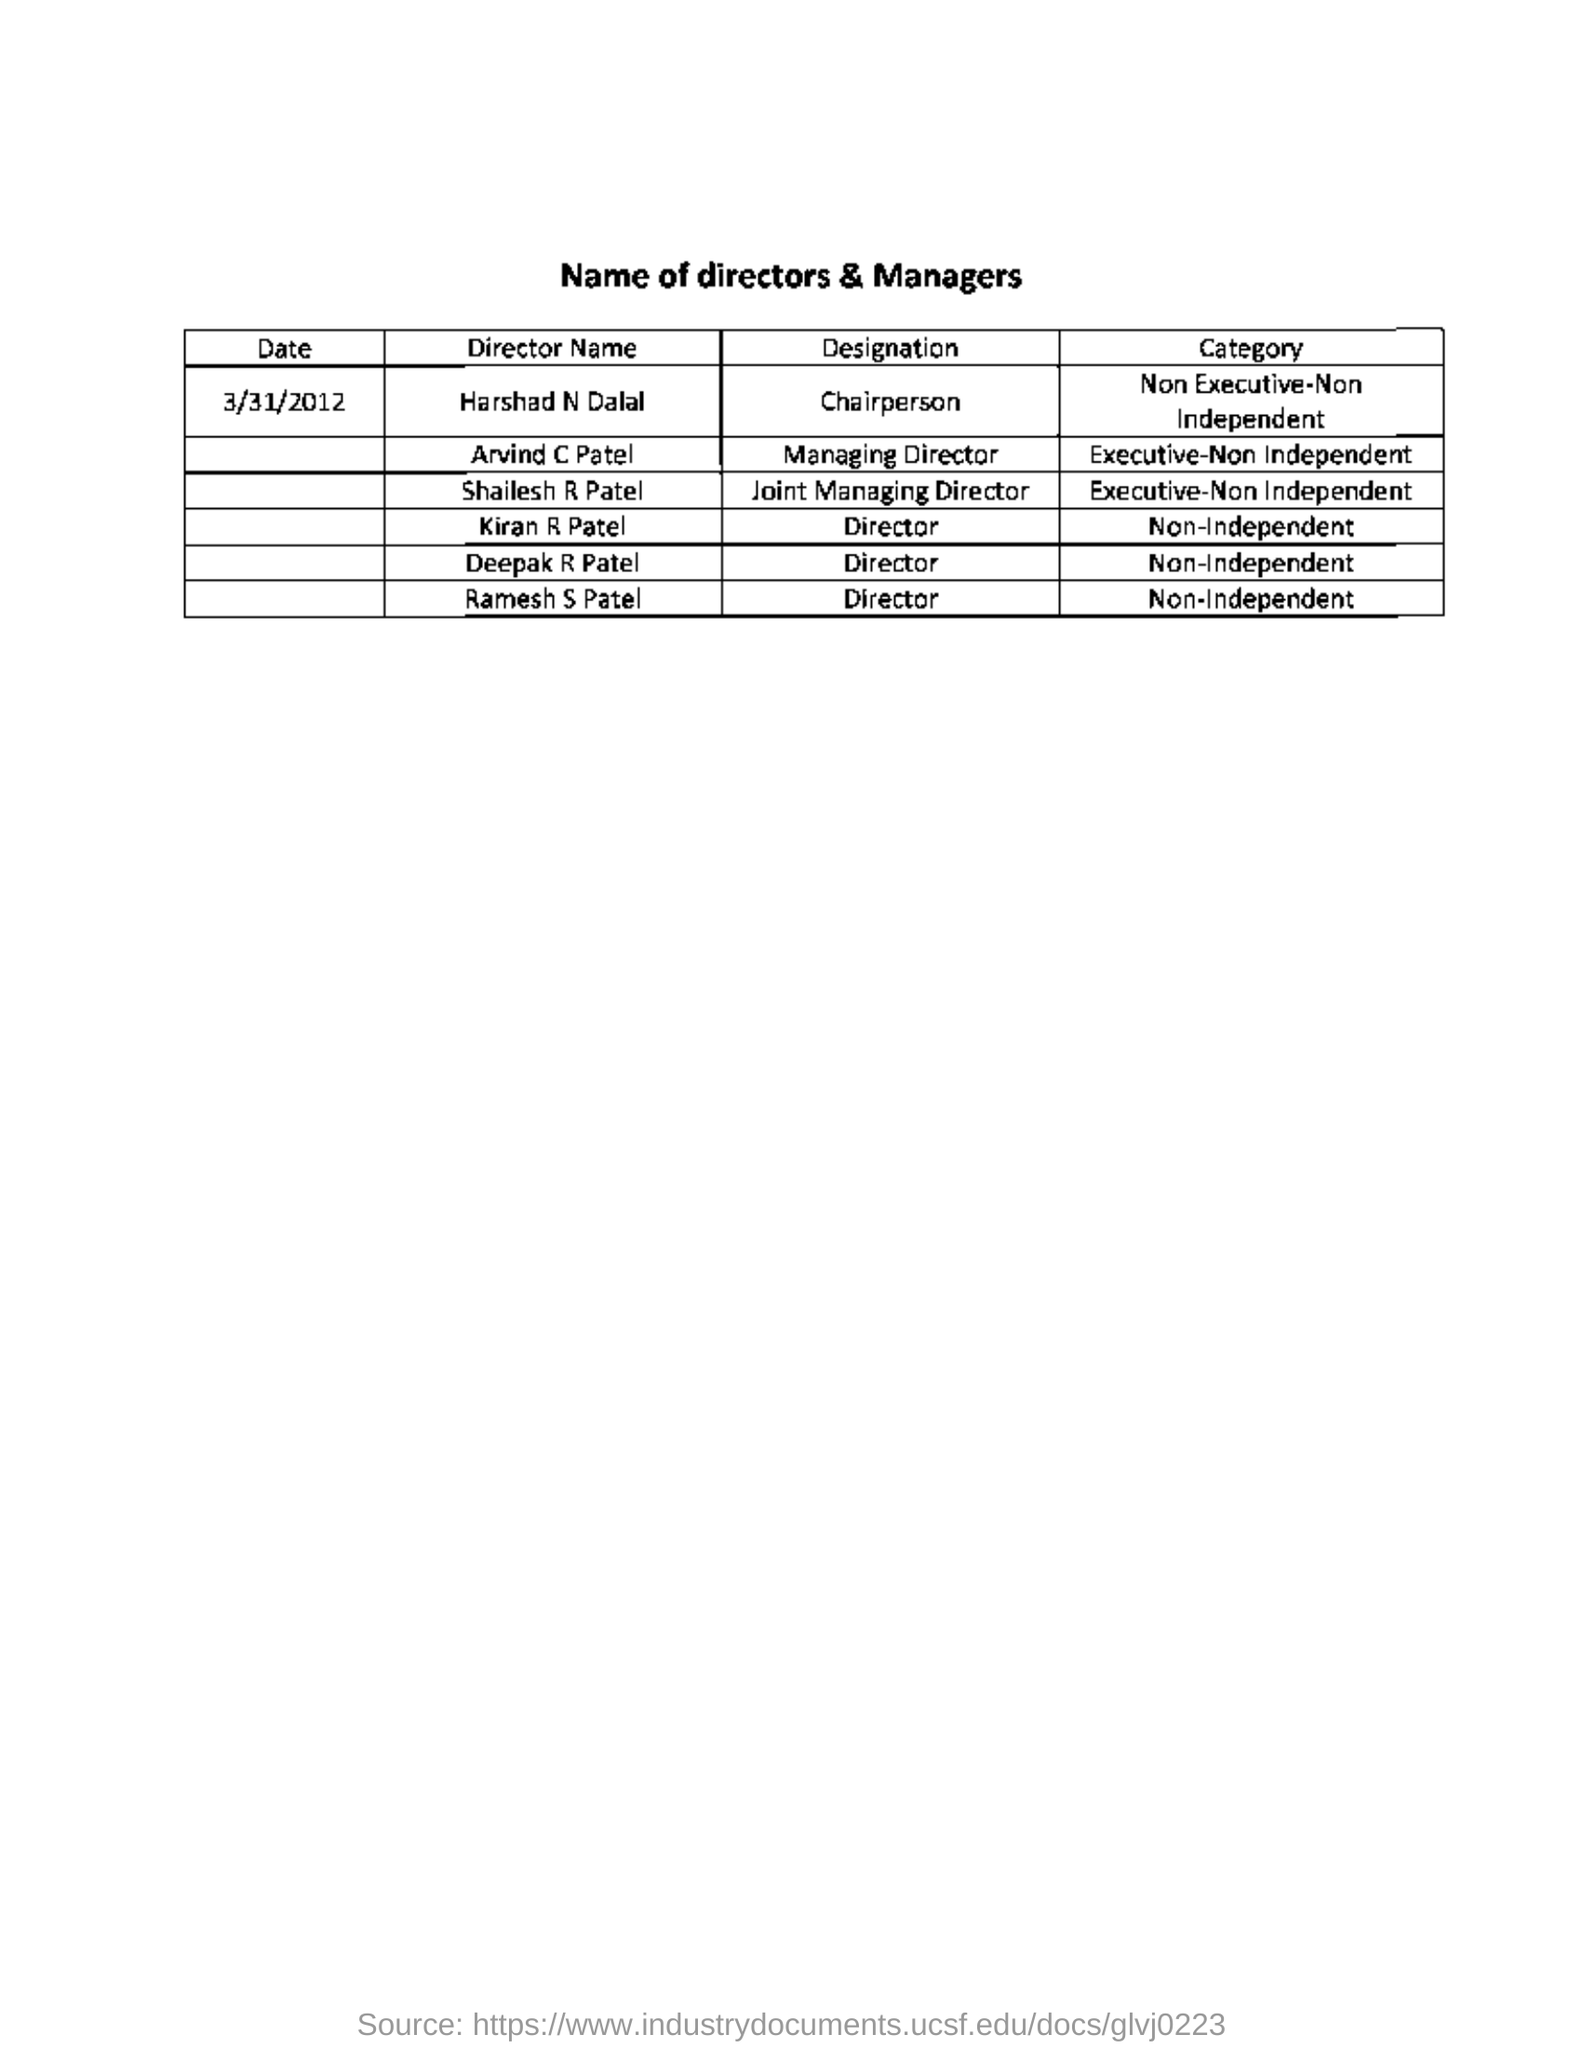Point out several critical features in this image. The date mentioned in this document is March 31, 2012. Ramesh S. Patel's designation for non-independent category is Director. Arvind C Patel holds the designation of Managing Director. Harshad N Dalal belongs to the category of Non-Executive-Non-Independent. 